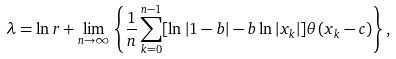<formula> <loc_0><loc_0><loc_500><loc_500>\lambda = \ln r + \lim _ { n \to \infty } \left \{ \frac { 1 } { n } \sum _ { k = 0 } ^ { n - 1 } [ \ln | 1 - b | - b \ln | x _ { k } | ] \theta ( x _ { k } - c ) \right \} ,</formula> 